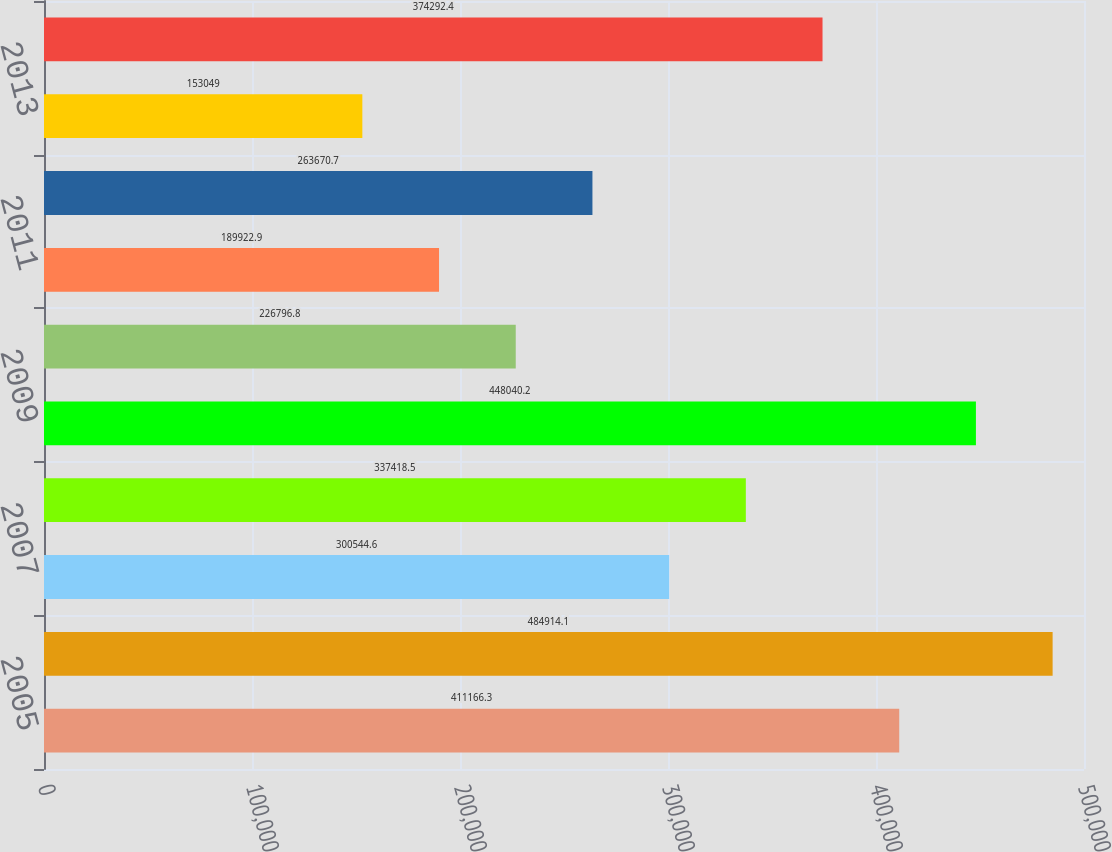Convert chart to OTSL. <chart><loc_0><loc_0><loc_500><loc_500><bar_chart><fcel>2005<fcel>2006<fcel>2007<fcel>2008<fcel>2009<fcel>2010<fcel>2011<fcel>2012<fcel>2013<fcel>2014<nl><fcel>411166<fcel>484914<fcel>300545<fcel>337418<fcel>448040<fcel>226797<fcel>189923<fcel>263671<fcel>153049<fcel>374292<nl></chart> 